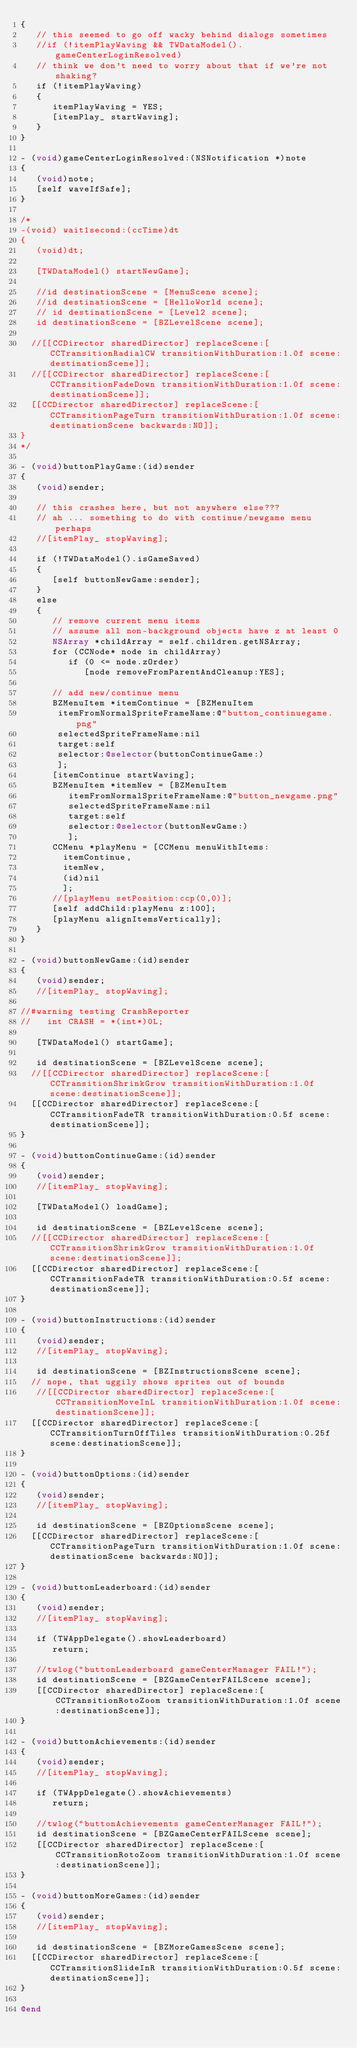Convert code to text. <code><loc_0><loc_0><loc_500><loc_500><_ObjectiveC_>{
   // this seemed to go off wacky behind dialogs sometimes
   //if (!itemPlayWaving && TWDataModel().gameCenterLoginResolved)
   // think we don't need to worry about that if we're not shaking?
   if (!itemPlayWaving)
   {
      itemPlayWaving = YES;
      [itemPlay_ startWaving];
   }
}

- (void)gameCenterLoginResolved:(NSNotification *)note
{
   (void)note;
   [self waveIfSafe];
}

/*
-(void) wait1second:(ccTime)dt
{
   (void)dt;
   
   [TWDataModel() startNewGame];
   
   //id destinationScene = [MenuScene scene];
   //id destinationScene = [HelloWorld scene];
   // id destinationScene = [Level2 scene];
   id destinationScene = [BZLevelScene scene];

	//[[CCDirector sharedDirector] replaceScene:[CCTransitionRadialCW transitionWithDuration:1.0f scene:destinationScene]];
	//[[CCDirector sharedDirector] replaceScene:[CCTransitionFadeDown transitionWithDuration:1.0f scene:destinationScene]];
	[[CCDirector sharedDirector] replaceScene:[CCTransitionPageTurn transitionWithDuration:1.0f scene:destinationScene backwards:NO]];
}
*/

- (void)buttonPlayGame:(id)sender
{
   (void)sender;
   
   // this crashes here, but not anywhere else???
   // ah ... something to do with continue/newgame menu perhaps
   //[itemPlay_ stopWaving];
   
   if (!TWDataModel().isGameSaved)
   {
      [self buttonNewGame:sender];
   }
   else
   {
      // remove current menu items
      // assume all non-background objects have z at least 0
      NSArray *childArray = self.children.getNSArray;
      for (CCNode* node in childArray)
         if (0 <= node.zOrder)
            [node removeFromParentAndCleanup:YES];
      
      // add new/continue menu
      BZMenuItem *itemContinue = [BZMenuItem
       itemFromNormalSpriteFrameName:@"button_continuegame.png"
       selectedSpriteFrameName:nil
       target:self
       selector:@selector(buttonContinueGame:)
       ];
      [itemContinue startWaving];
      BZMenuItem *itemNew = [BZMenuItem
         itemFromNormalSpriteFrameName:@"button_newgame.png"
         selectedSpriteFrameName:nil
         target:self
         selector:@selector(buttonNewGame:)
         ];
      CCMenu *playMenu = [CCMenu menuWithItems:
        itemContinue,
        itemNew,
        (id)nil
        ];
      //[playMenu setPosition:ccp(0,0)];
      [self addChild:playMenu z:100];
      [playMenu alignItemsVertically];
   }
}

- (void)buttonNewGame:(id)sender
{
   (void)sender;
   //[itemPlay_ stopWaving];
  
//#warning testing CrashReporter
//   int CRASH = *(int*)0L;
   
   [TWDataModel() startGame];
   
   id destinationScene = [BZLevelScene scene];
	//[[CCDirector sharedDirector] replaceScene:[CCTransitionShrinkGrow transitionWithDuration:1.0f scene:destinationScene]];
	[[CCDirector sharedDirector] replaceScene:[CCTransitionFadeTR transitionWithDuration:0.5f scene:destinationScene]];
}

- (void)buttonContinueGame:(id)sender
{
   (void)sender;
   //[itemPlay_ stopWaving];
   
   [TWDataModel() loadGame];
   
   id destinationScene = [BZLevelScene scene];
	//[[CCDirector sharedDirector] replaceScene:[CCTransitionShrinkGrow transitionWithDuration:1.0f scene:destinationScene]];
	[[CCDirector sharedDirector] replaceScene:[CCTransitionFadeTR transitionWithDuration:0.5f scene:destinationScene]];
}

- (void)buttonInstructions:(id)sender
{
   (void)sender;
   //[itemPlay_ stopWaving];
   
   id destinationScene = [BZInstructionsScene scene];
	// nope, that uggily shows sprites out of bounds
   //[[CCDirector sharedDirector] replaceScene:[CCTransitionMoveInL transitionWithDuration:1.0f scene:destinationScene]];
	[[CCDirector sharedDirector] replaceScene:[CCTransitionTurnOffTiles transitionWithDuration:0.25f scene:destinationScene]];
}

- (void)buttonOptions:(id)sender
{
   (void)sender;
   //[itemPlay_ stopWaving];
   
   id destinationScene = [BZOptionsScene scene];
	[[CCDirector sharedDirector] replaceScene:[CCTransitionPageTurn transitionWithDuration:1.0f scene:destinationScene backwards:NO]];
}

- (void)buttonLeaderboard:(id)sender
{
   (void)sender;
   //[itemPlay_ stopWaving];
   
   if (TWAppDelegate().showLeaderboard)
      return;
   
   //twlog("buttonLeaderboard gameCenterManager FAIL!");
   id destinationScene = [BZGameCenterFAILScene scene];
   [[CCDirector sharedDirector] replaceScene:[CCTransitionRotoZoom transitionWithDuration:1.0f scene:destinationScene]];      
}

- (void)buttonAchievements:(id)sender
{
   (void)sender;
   //[itemPlay_ stopWaving];
  
   if (TWAppDelegate().showAchievements)
      return;
   
   //twlog("buttonAchievements gameCenterManager FAIL!");
   id destinationScene = [BZGameCenterFAILScene scene];
   [[CCDirector sharedDirector] replaceScene:[CCTransitionRotoZoom transitionWithDuration:1.0f scene:destinationScene]];
}

- (void)buttonMoreGames:(id)sender
{
   (void)sender;
   //[itemPlay_ stopWaving];
  
   id destinationScene = [BZMoreGamesScene scene];
	[[CCDirector sharedDirector] replaceScene:[CCTransitionSlideInR transitionWithDuration:0.5f scene:destinationScene]];
}

@end
</code> 